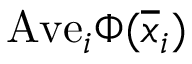Convert formula to latex. <formula><loc_0><loc_0><loc_500><loc_500>A v e _ { i } \Phi ( \overline { x } _ { i } )</formula> 